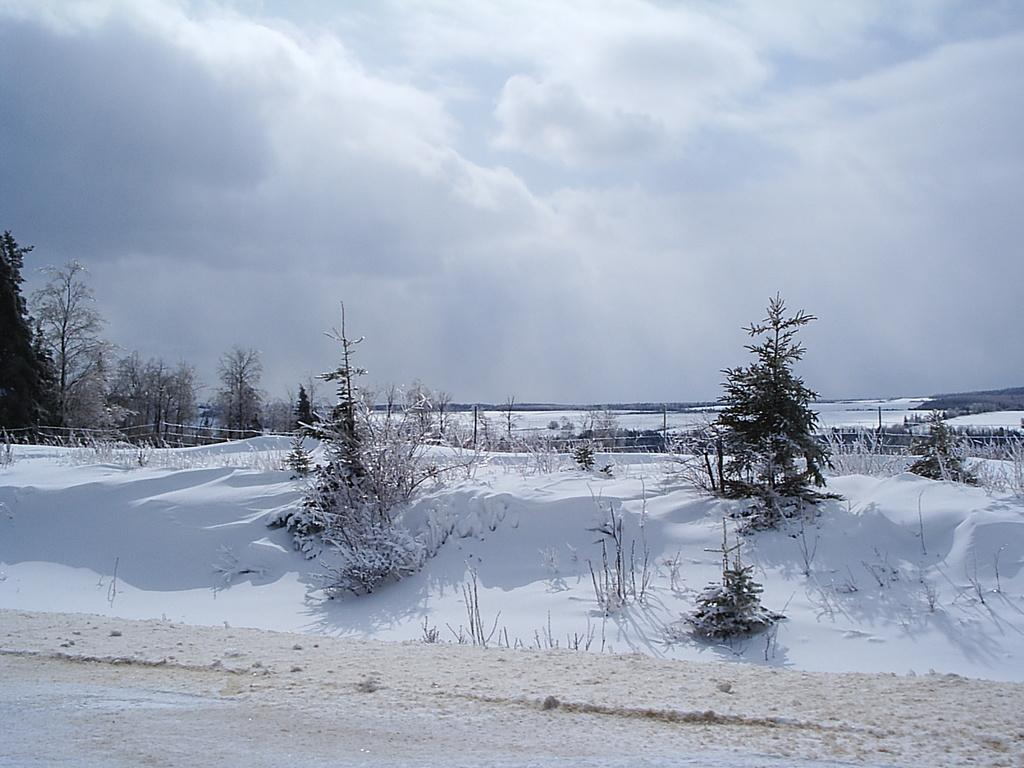What type of vegetation can be seen in the image? There are trees and plants in the image. What is visible in the sky in the image? There are clouds in the sky. What type of coil can be seen in the image? There is no coil present in the image. What type of ocean can be seen in the image? There is no ocean present in the image. 